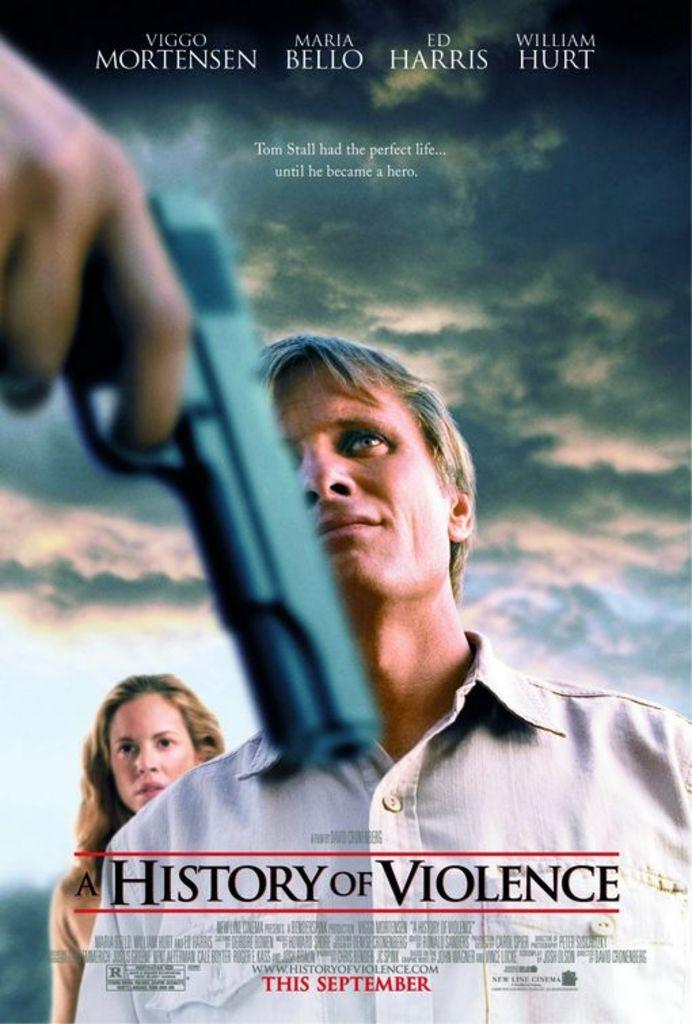What is the gender of the person standing on the left side of the image? There is a man standing in the image. What is the man wearing in the image? The man is wearing a shirt. What is the gender of the person standing on the right side of the image? There is a woman standing in the image. Can you describe the person holding an object in the image? There is a person holding a gun in the image. Where is the throne located in the image? There is no throne present in the image. What type of ink is being used by the person holding the gun in the image? There is no ink present in the image, as it features a person holding a gun, not writing or drawing. 